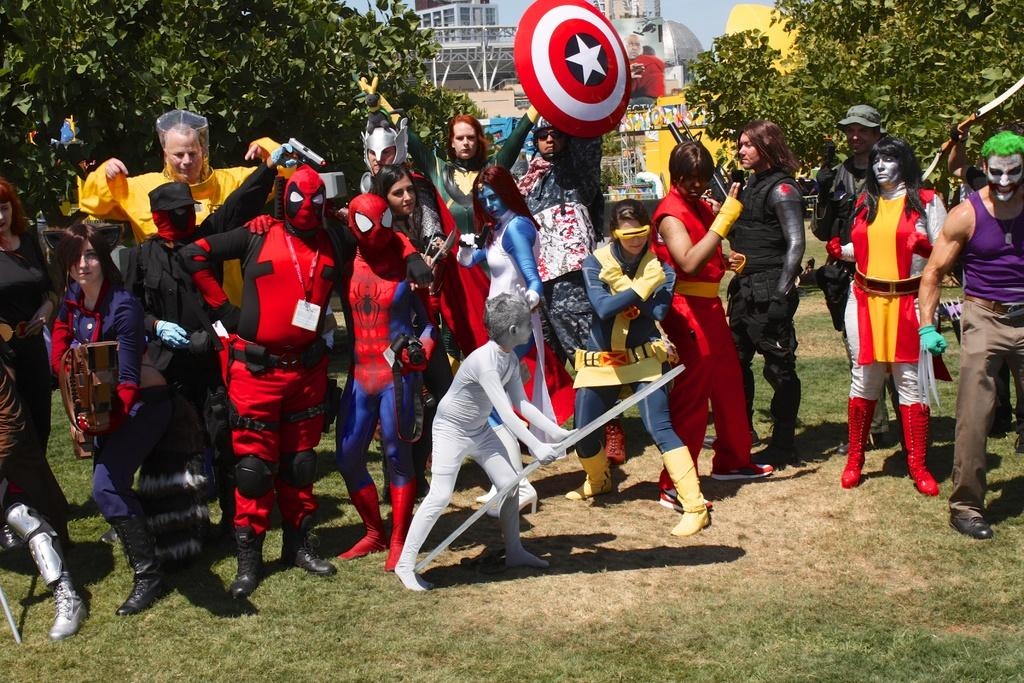What type of surface is at the bottom of the image? There is grass at the bottom of the image. What can be seen in the middle of the image? There are people standing in the middle of the image. What are the people holding in their hands? The people are holding something in their hands. What is visible behind the people? There are trees behind the people. What is visible behind the trees? There are buildings behind the trees. What is the name of the basketball team the people are cheering for in the image? There is no basketball team or any reference to a basketball game in the image. 